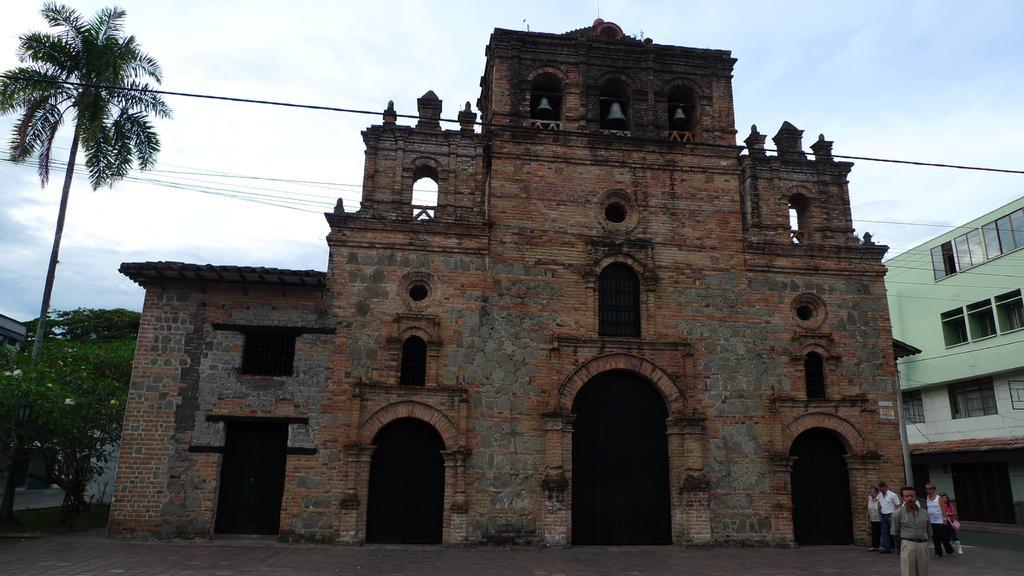How would you summarize this image in a sentence or two? In this image there is the sky towards the top of the image, there are buildings, there are doors, there are windows, there are trees towards the left of the image, there is a wire, there are two men and one woman walking, there is a man standing towards the bottom of the image. 